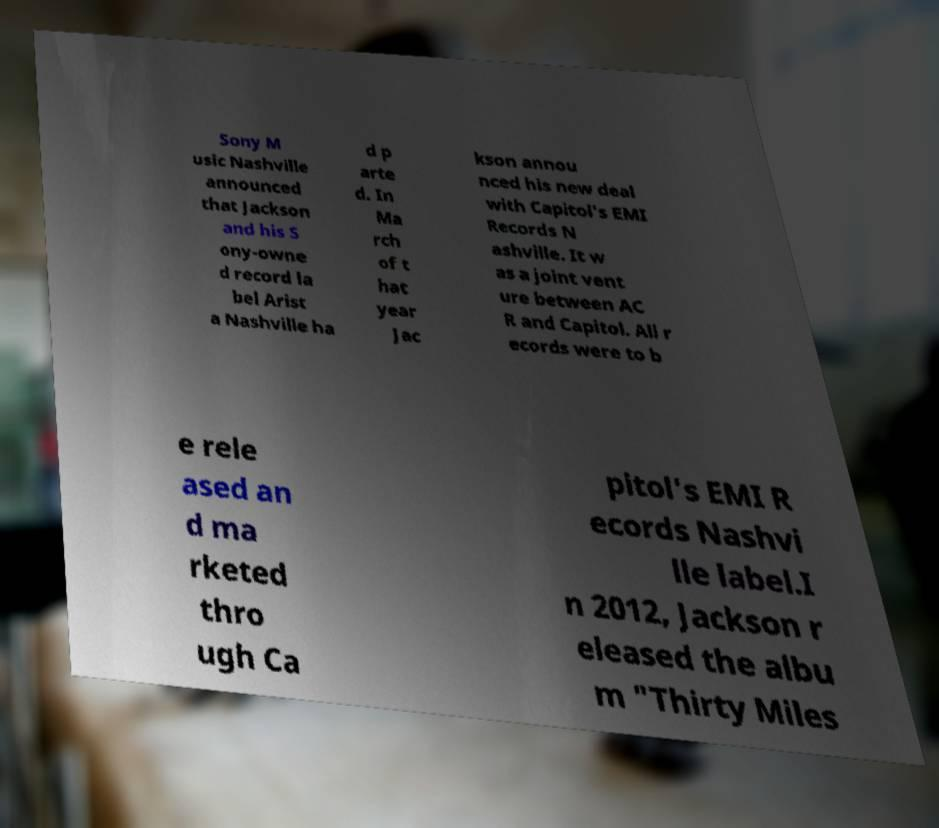Please identify and transcribe the text found in this image. Sony M usic Nashville announced that Jackson and his S ony-owne d record la bel Arist a Nashville ha d p arte d. In Ma rch of t hat year Jac kson annou nced his new deal with Capitol's EMI Records N ashville. It w as a joint vent ure between AC R and Capitol. All r ecords were to b e rele ased an d ma rketed thro ugh Ca pitol's EMI R ecords Nashvi lle label.I n 2012, Jackson r eleased the albu m "Thirty Miles 